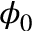<formula> <loc_0><loc_0><loc_500><loc_500>\phi _ { 0 }</formula> 